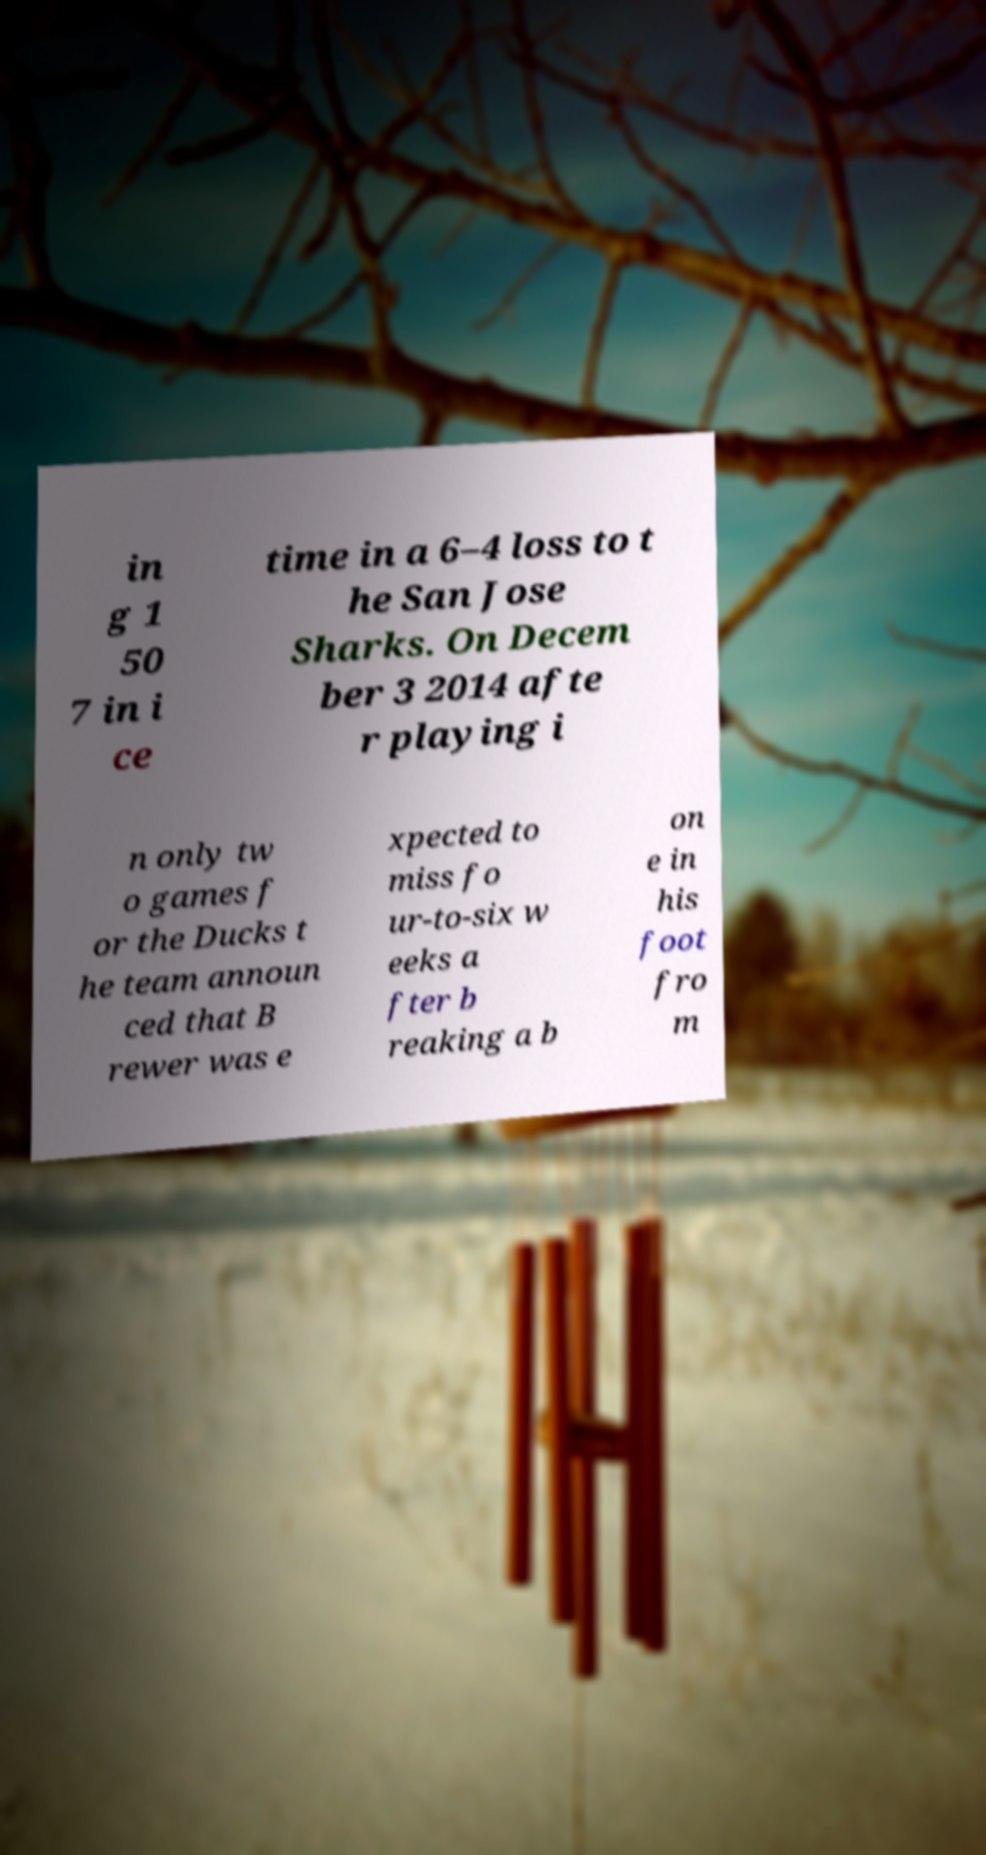For documentation purposes, I need the text within this image transcribed. Could you provide that? in g 1 50 7 in i ce time in a 6–4 loss to t he San Jose Sharks. On Decem ber 3 2014 afte r playing i n only tw o games f or the Ducks t he team announ ced that B rewer was e xpected to miss fo ur-to-six w eeks a fter b reaking a b on e in his foot fro m 